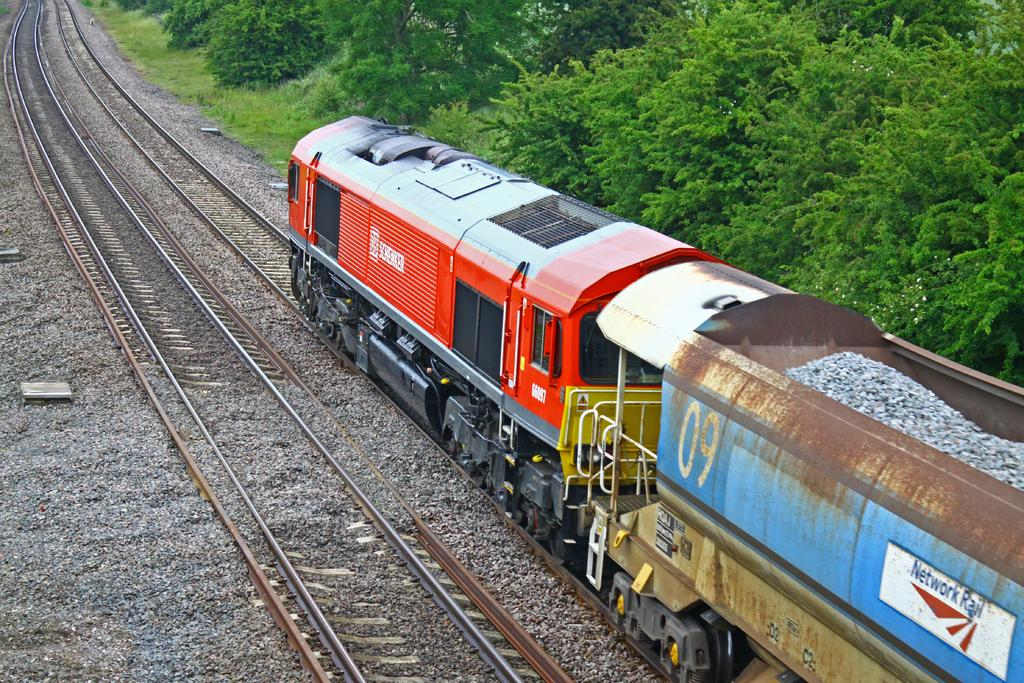What is the main subject of the image? The main subject of the image is a train. Where is the train located in the image? The train is on a railway track. Are there any other railway tracks visible in the image? Yes, there is another railway track visible in the image. What type of natural elements can be seen in the image? There are trees in the image. What is the ground surface like in the image? The ground surface has small stones visible in the image. How many oranges are hanging from the trees in the image? There are no oranges present in the image; it only features a train, railway tracks, trees, and small stones on the ground. 